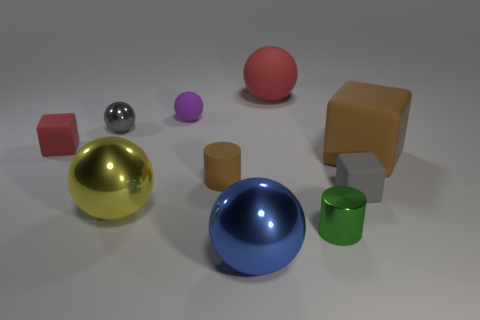Subtract all gray blocks. How many blocks are left? 2 Subtract all cylinders. How many objects are left? 8 Subtract all yellow spheres. How many spheres are left? 4 Subtract 1 gray cubes. How many objects are left? 9 Subtract 3 balls. How many balls are left? 2 Subtract all green blocks. Subtract all green balls. How many blocks are left? 3 Subtract all big blue metallic objects. Subtract all red cubes. How many objects are left? 8 Add 2 gray cubes. How many gray cubes are left? 3 Add 4 large yellow spheres. How many large yellow spheres exist? 5 